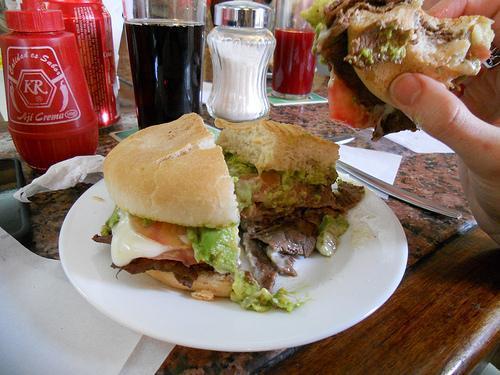How many salt shakers is there?
Give a very brief answer. 1. 